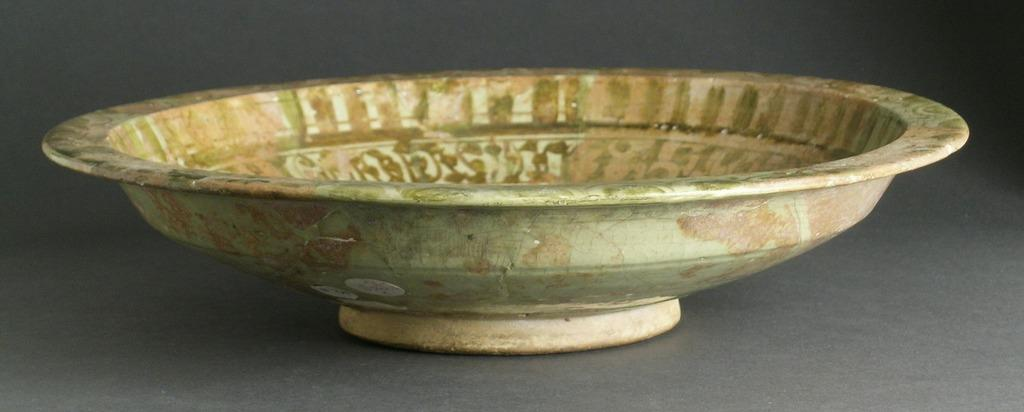What type of dish is present in the image? There is a ceramic dish in the image. What type of ornament is hanging from the wheel in the image? There is no wheel or ornament present in the image; it only features a ceramic dish. 